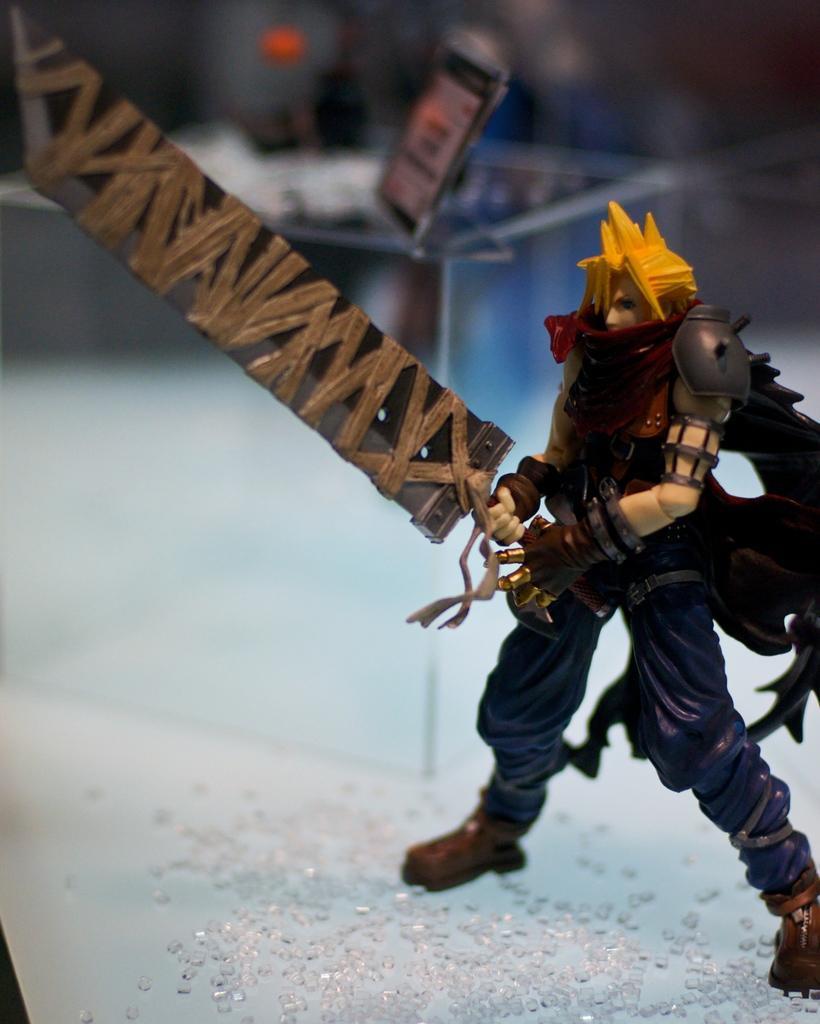In one or two sentences, can you explain what this image depicts? In this image we can see a toy and some crystals on the surface. On the backside we can see an object on a glass container. 